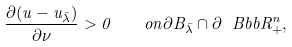<formula> <loc_0><loc_0><loc_500><loc_500>\frac { \partial ( u - u _ { \bar { \lambda } } ) } { \partial \nu } > 0 \quad o n \partial B _ { \bar { \lambda } } \cap \partial \ B b b { R } ^ { n } _ { + } ,</formula> 